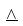Convert formula to latex. <formula><loc_0><loc_0><loc_500><loc_500>\underline { \wedge }</formula> 